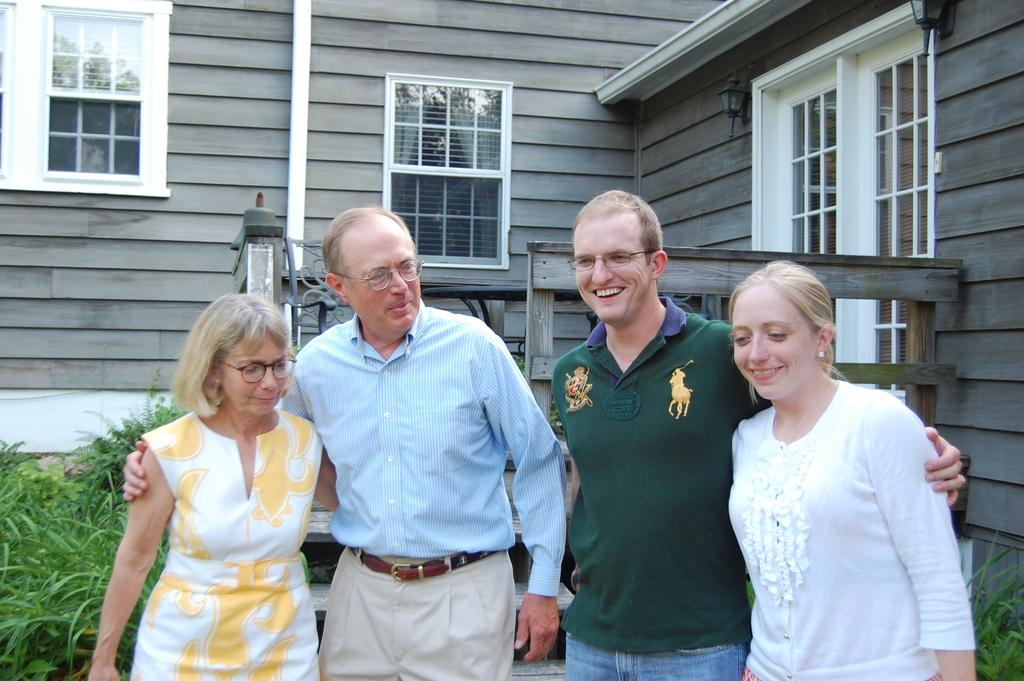Who or what can be seen in the image? There are people in the image. What is the setting or location of the people? The people are standing in front of a house. What are the people doing in the image? The people are talking to each other. Where is the nearest store to the people in the image? There is no information about a store in the image or its location. 